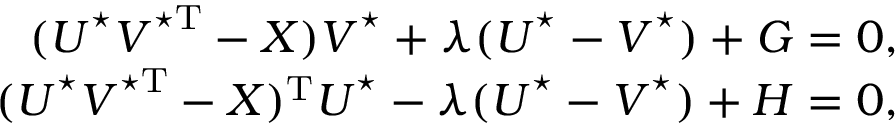<formula> <loc_0><loc_0><loc_500><loc_500>\begin{array} { r } { ( U ^ { ^ { * } } V ^ { ^ { * } T } - X ) V ^ { ^ { * } } + \lambda ( U ^ { ^ { * } } - V ^ { ^ { * } } ) + G = 0 , } \\ { ( U ^ { ^ { * } } V ^ { ^ { * } T } - X ) ^ { T } U ^ { ^ { * } } - \lambda ( U ^ { ^ { * } } - V ^ { ^ { * } } ) + H = 0 , } \end{array}</formula> 